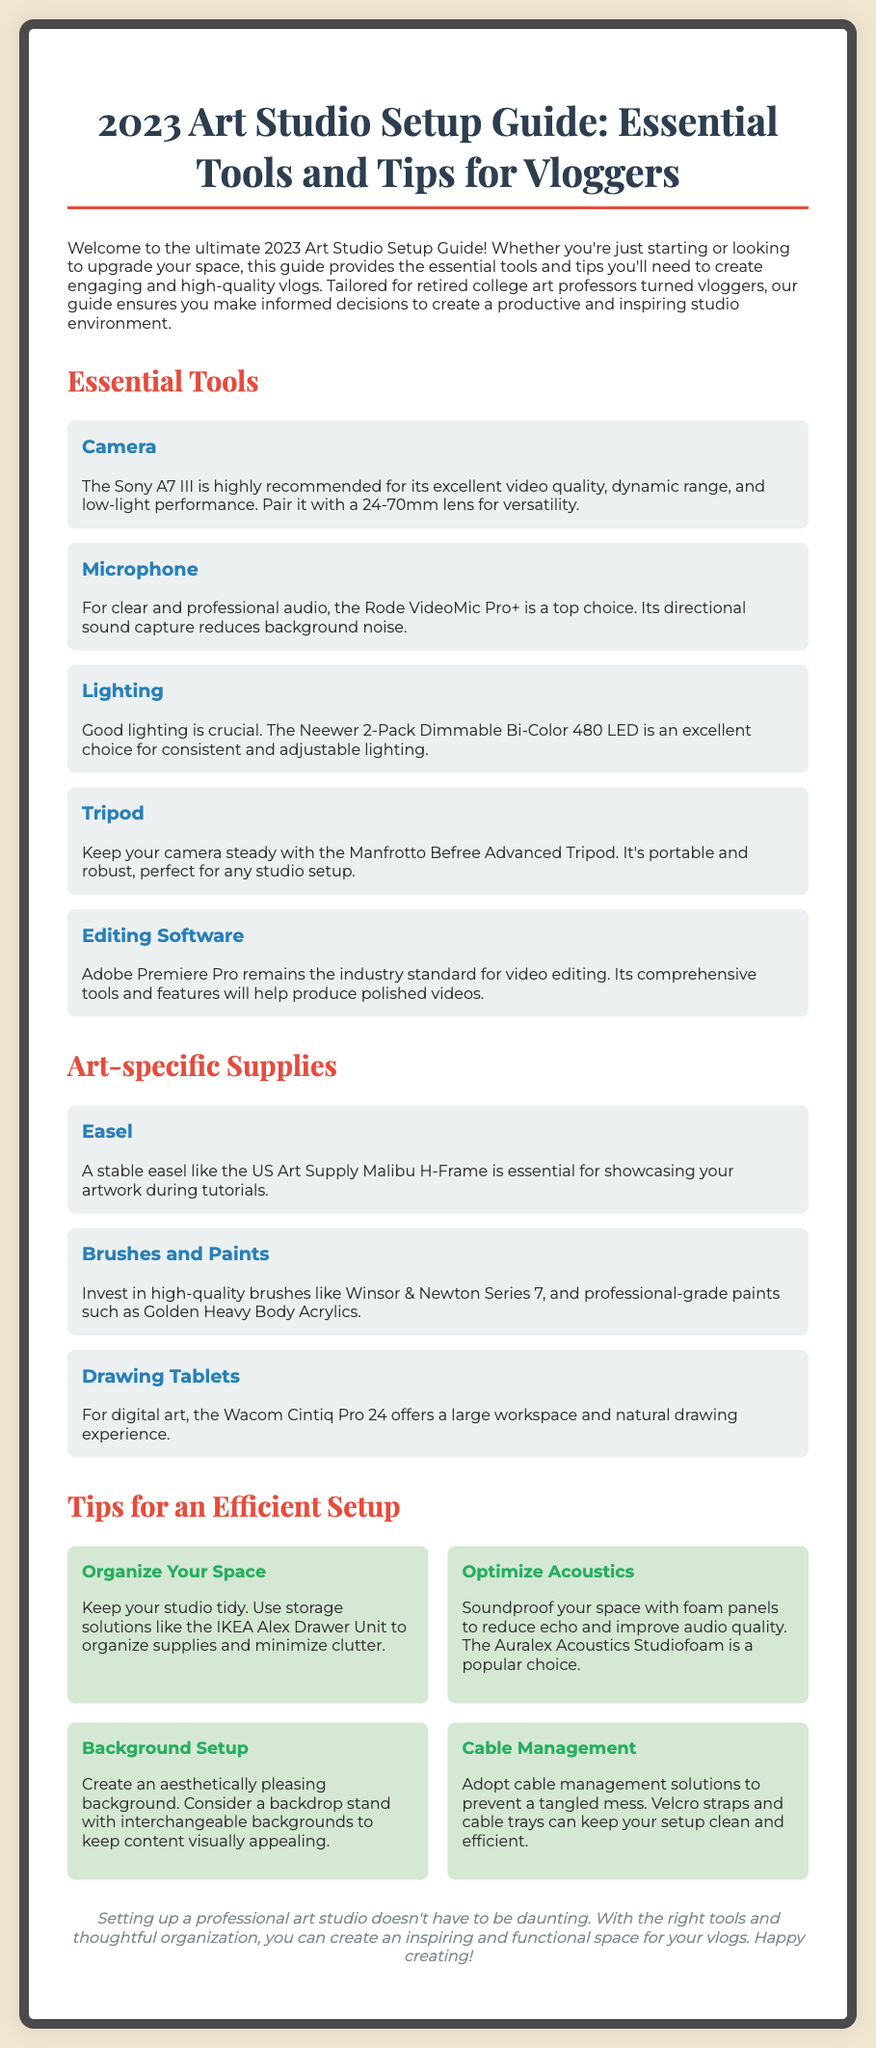What is the recommended camera? The document recommends the Sony A7 III for its excellent video quality and performance.
Answer: Sony A7 III What is the purpose of the Rode VideoMic Pro+? The Rode VideoMic Pro+ is used for clear and professional audio, reducing background noise.
Answer: Clear audio What is the lighting equipment suggested in the guide? The guide suggests the Neewer 2-Pack Dimmable Bi-Color 480 LED for lighting.
Answer: Neewer 2-Pack Dimmable Bi-Color 480 LED How many types of essential tools are listed in the document? There are five essential tools listed in the document.
Answer: Five What is a good practice for studio organization? Using storage solutions like the IKEA Alex Drawer Unit is recommended for organization.
Answer: IKEA Alex Drawer Unit Which drawing tablet is mentioned for digital art? The Wacom Cintiq Pro 24 is the recommended drawing tablet for digital art in the guide.
Answer: Wacom Cintiq Pro 24 What type of panels can improve audio quality? Foam panels can be used to reduce echo and improve audio quality.
Answer: Foam panels What color is the background of the poster? The background color of the poster is light beige (#f0e6d2).
Answer: Light beige What does the conclusion emphasize? The conclusion emphasizes creating an inspiring and functional space for vlogs.
Answer: Inspiring and functional space 